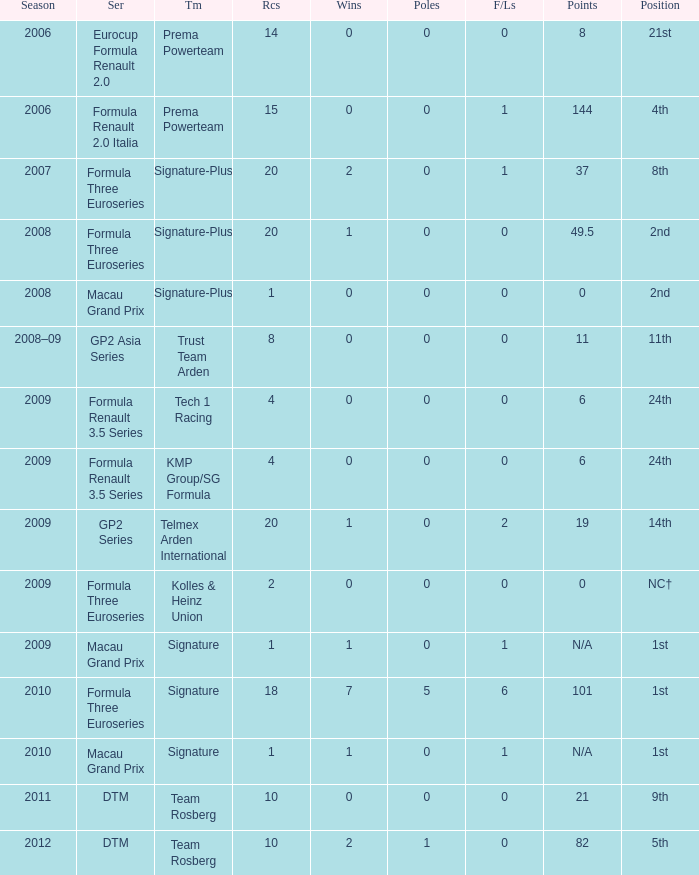How many poles are there in the 2009 season with 2 races and more than 0 F/Laps? 0.0. 